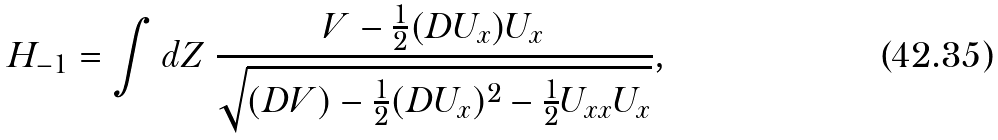<formula> <loc_0><loc_0><loc_500><loc_500>H _ { - 1 } = \int d Z \ \frac { V - \frac { 1 } { 2 } ( D U _ { x } ) U _ { x } } { \sqrt { ( D V ) - \frac { 1 } { 2 } ( D U _ { x } ) ^ { 2 } - \frac { 1 } { 2 } U _ { x x } U _ { x } } } ,</formula> 